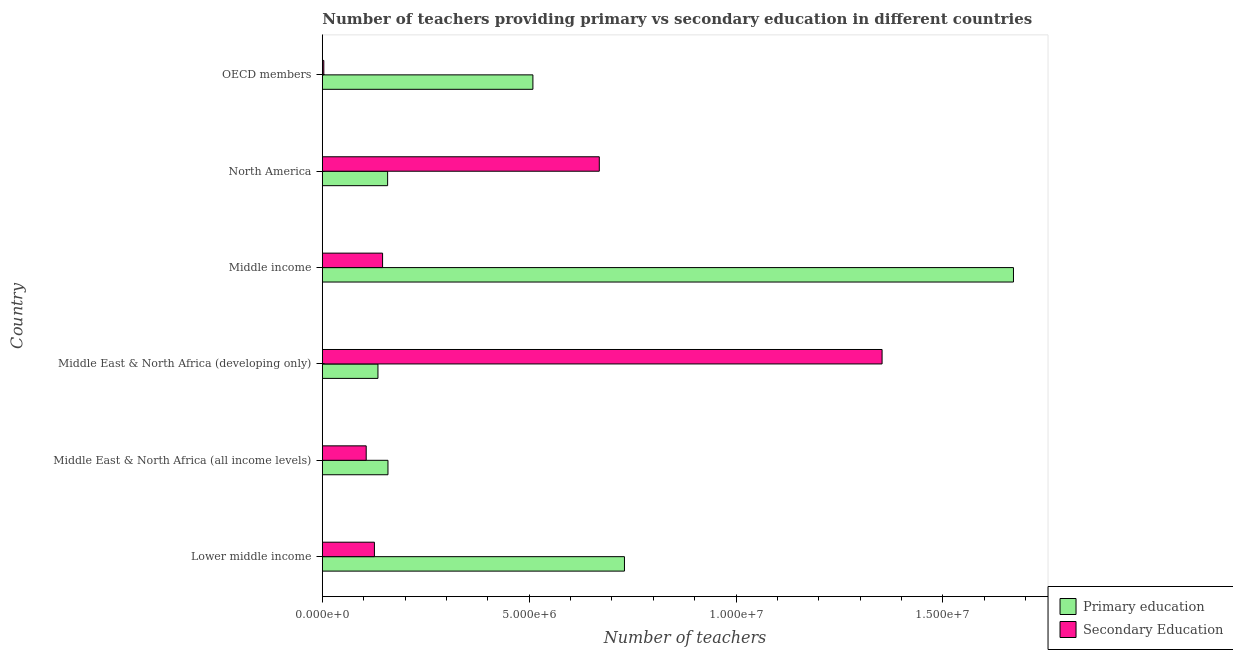How many groups of bars are there?
Keep it short and to the point. 6. How many bars are there on the 3rd tick from the bottom?
Provide a short and direct response. 2. What is the label of the 5th group of bars from the top?
Make the answer very short. Middle East & North Africa (all income levels). In how many cases, is the number of bars for a given country not equal to the number of legend labels?
Ensure brevity in your answer.  0. What is the number of secondary teachers in Middle income?
Provide a short and direct response. 1.46e+06. Across all countries, what is the maximum number of primary teachers?
Your answer should be compact. 1.67e+07. Across all countries, what is the minimum number of primary teachers?
Offer a very short reply. 1.34e+06. In which country was the number of secondary teachers maximum?
Give a very brief answer. Middle East & North Africa (developing only). In which country was the number of secondary teachers minimum?
Provide a succinct answer. OECD members. What is the total number of primary teachers in the graph?
Provide a succinct answer. 3.36e+07. What is the difference between the number of primary teachers in Middle East & North Africa (all income levels) and that in Middle income?
Your response must be concise. -1.51e+07. What is the difference between the number of secondary teachers in North America and the number of primary teachers in Middle East & North Africa (all income levels)?
Provide a short and direct response. 5.11e+06. What is the average number of primary teachers per country?
Keep it short and to the point. 5.60e+06. What is the difference between the number of primary teachers and number of secondary teachers in Middle income?
Your answer should be very brief. 1.52e+07. In how many countries, is the number of primary teachers greater than 10000000 ?
Ensure brevity in your answer.  1. What is the ratio of the number of primary teachers in Middle East & North Africa (developing only) to that in OECD members?
Keep it short and to the point. 0.26. Is the difference between the number of primary teachers in Lower middle income and Middle income greater than the difference between the number of secondary teachers in Lower middle income and Middle income?
Offer a very short reply. No. What is the difference between the highest and the second highest number of secondary teachers?
Make the answer very short. 6.83e+06. What is the difference between the highest and the lowest number of primary teachers?
Offer a very short reply. 1.54e+07. What does the 1st bar from the top in Middle East & North Africa (all income levels) represents?
Ensure brevity in your answer.  Secondary Education. What does the 2nd bar from the bottom in North America represents?
Provide a short and direct response. Secondary Education. How many bars are there?
Your answer should be very brief. 12. What is the difference between two consecutive major ticks on the X-axis?
Ensure brevity in your answer.  5.00e+06. Does the graph contain grids?
Your response must be concise. No. How are the legend labels stacked?
Offer a terse response. Vertical. What is the title of the graph?
Your answer should be very brief. Number of teachers providing primary vs secondary education in different countries. What is the label or title of the X-axis?
Provide a succinct answer. Number of teachers. What is the Number of teachers in Primary education in Lower middle income?
Your answer should be very brief. 7.30e+06. What is the Number of teachers of Secondary Education in Lower middle income?
Your answer should be compact. 1.26e+06. What is the Number of teachers of Primary education in Middle East & North Africa (all income levels)?
Provide a short and direct response. 1.59e+06. What is the Number of teachers in Secondary Education in Middle East & North Africa (all income levels)?
Ensure brevity in your answer.  1.06e+06. What is the Number of teachers in Primary education in Middle East & North Africa (developing only)?
Make the answer very short. 1.34e+06. What is the Number of teachers of Secondary Education in Middle East & North Africa (developing only)?
Keep it short and to the point. 1.35e+07. What is the Number of teachers of Primary education in Middle income?
Offer a terse response. 1.67e+07. What is the Number of teachers of Secondary Education in Middle income?
Ensure brevity in your answer.  1.46e+06. What is the Number of teachers in Primary education in North America?
Make the answer very short. 1.58e+06. What is the Number of teachers of Secondary Education in North America?
Give a very brief answer. 6.69e+06. What is the Number of teachers in Primary education in OECD members?
Offer a very short reply. 5.09e+06. What is the Number of teachers of Secondary Education in OECD members?
Your response must be concise. 3.58e+04. Across all countries, what is the maximum Number of teachers of Primary education?
Offer a terse response. 1.67e+07. Across all countries, what is the maximum Number of teachers in Secondary Education?
Ensure brevity in your answer.  1.35e+07. Across all countries, what is the minimum Number of teachers of Primary education?
Your answer should be very brief. 1.34e+06. Across all countries, what is the minimum Number of teachers of Secondary Education?
Make the answer very short. 3.58e+04. What is the total Number of teachers of Primary education in the graph?
Provide a short and direct response. 3.36e+07. What is the total Number of teachers in Secondary Education in the graph?
Keep it short and to the point. 2.40e+07. What is the difference between the Number of teachers of Primary education in Lower middle income and that in Middle East & North Africa (all income levels)?
Ensure brevity in your answer.  5.72e+06. What is the difference between the Number of teachers of Secondary Education in Lower middle income and that in Middle East & North Africa (all income levels)?
Your answer should be very brief. 1.99e+05. What is the difference between the Number of teachers of Primary education in Lower middle income and that in Middle East & North Africa (developing only)?
Ensure brevity in your answer.  5.96e+06. What is the difference between the Number of teachers of Secondary Education in Lower middle income and that in Middle East & North Africa (developing only)?
Your response must be concise. -1.23e+07. What is the difference between the Number of teachers of Primary education in Lower middle income and that in Middle income?
Ensure brevity in your answer.  -9.40e+06. What is the difference between the Number of teachers of Secondary Education in Lower middle income and that in Middle income?
Give a very brief answer. -1.97e+05. What is the difference between the Number of teachers of Primary education in Lower middle income and that in North America?
Your answer should be very brief. 5.72e+06. What is the difference between the Number of teachers in Secondary Education in Lower middle income and that in North America?
Give a very brief answer. -5.43e+06. What is the difference between the Number of teachers in Primary education in Lower middle income and that in OECD members?
Offer a terse response. 2.21e+06. What is the difference between the Number of teachers in Secondary Education in Lower middle income and that in OECD members?
Provide a succinct answer. 1.22e+06. What is the difference between the Number of teachers in Primary education in Middle East & North Africa (all income levels) and that in Middle East & North Africa (developing only)?
Provide a short and direct response. 2.42e+05. What is the difference between the Number of teachers of Secondary Education in Middle East & North Africa (all income levels) and that in Middle East & North Africa (developing only)?
Give a very brief answer. -1.25e+07. What is the difference between the Number of teachers in Primary education in Middle East & North Africa (all income levels) and that in Middle income?
Ensure brevity in your answer.  -1.51e+07. What is the difference between the Number of teachers of Secondary Education in Middle East & North Africa (all income levels) and that in Middle income?
Offer a terse response. -3.96e+05. What is the difference between the Number of teachers in Primary education in Middle East & North Africa (all income levels) and that in North America?
Provide a short and direct response. 8263.25. What is the difference between the Number of teachers of Secondary Education in Middle East & North Africa (all income levels) and that in North America?
Make the answer very short. -5.63e+06. What is the difference between the Number of teachers of Primary education in Middle East & North Africa (all income levels) and that in OECD members?
Keep it short and to the point. -3.50e+06. What is the difference between the Number of teachers in Secondary Education in Middle East & North Africa (all income levels) and that in OECD members?
Ensure brevity in your answer.  1.02e+06. What is the difference between the Number of teachers of Primary education in Middle East & North Africa (developing only) and that in Middle income?
Provide a succinct answer. -1.54e+07. What is the difference between the Number of teachers of Secondary Education in Middle East & North Africa (developing only) and that in Middle income?
Give a very brief answer. 1.21e+07. What is the difference between the Number of teachers in Primary education in Middle East & North Africa (developing only) and that in North America?
Offer a terse response. -2.34e+05. What is the difference between the Number of teachers of Secondary Education in Middle East & North Africa (developing only) and that in North America?
Make the answer very short. 6.83e+06. What is the difference between the Number of teachers of Primary education in Middle East & North Africa (developing only) and that in OECD members?
Provide a short and direct response. -3.74e+06. What is the difference between the Number of teachers of Secondary Education in Middle East & North Africa (developing only) and that in OECD members?
Offer a very short reply. 1.35e+07. What is the difference between the Number of teachers in Primary education in Middle income and that in North America?
Offer a very short reply. 1.51e+07. What is the difference between the Number of teachers in Secondary Education in Middle income and that in North America?
Your answer should be very brief. -5.24e+06. What is the difference between the Number of teachers in Primary education in Middle income and that in OECD members?
Your answer should be very brief. 1.16e+07. What is the difference between the Number of teachers of Secondary Education in Middle income and that in OECD members?
Keep it short and to the point. 1.42e+06. What is the difference between the Number of teachers in Primary education in North America and that in OECD members?
Your answer should be very brief. -3.51e+06. What is the difference between the Number of teachers of Secondary Education in North America and that in OECD members?
Offer a terse response. 6.66e+06. What is the difference between the Number of teachers in Primary education in Lower middle income and the Number of teachers in Secondary Education in Middle East & North Africa (all income levels)?
Keep it short and to the point. 6.24e+06. What is the difference between the Number of teachers in Primary education in Lower middle income and the Number of teachers in Secondary Education in Middle East & North Africa (developing only)?
Your response must be concise. -6.23e+06. What is the difference between the Number of teachers in Primary education in Lower middle income and the Number of teachers in Secondary Education in Middle income?
Ensure brevity in your answer.  5.85e+06. What is the difference between the Number of teachers in Primary education in Lower middle income and the Number of teachers in Secondary Education in North America?
Your answer should be compact. 6.08e+05. What is the difference between the Number of teachers in Primary education in Lower middle income and the Number of teachers in Secondary Education in OECD members?
Provide a short and direct response. 7.27e+06. What is the difference between the Number of teachers of Primary education in Middle East & North Africa (all income levels) and the Number of teachers of Secondary Education in Middle East & North Africa (developing only)?
Offer a very short reply. -1.19e+07. What is the difference between the Number of teachers in Primary education in Middle East & North Africa (all income levels) and the Number of teachers in Secondary Education in Middle income?
Keep it short and to the point. 1.30e+05. What is the difference between the Number of teachers in Primary education in Middle East & North Africa (all income levels) and the Number of teachers in Secondary Education in North America?
Make the answer very short. -5.11e+06. What is the difference between the Number of teachers of Primary education in Middle East & North Africa (all income levels) and the Number of teachers of Secondary Education in OECD members?
Your response must be concise. 1.55e+06. What is the difference between the Number of teachers of Primary education in Middle East & North Africa (developing only) and the Number of teachers of Secondary Education in Middle income?
Your answer should be very brief. -1.11e+05. What is the difference between the Number of teachers in Primary education in Middle East & North Africa (developing only) and the Number of teachers in Secondary Education in North America?
Provide a short and direct response. -5.35e+06. What is the difference between the Number of teachers in Primary education in Middle East & North Africa (developing only) and the Number of teachers in Secondary Education in OECD members?
Provide a short and direct response. 1.31e+06. What is the difference between the Number of teachers in Primary education in Middle income and the Number of teachers in Secondary Education in North America?
Your answer should be compact. 1.00e+07. What is the difference between the Number of teachers of Primary education in Middle income and the Number of teachers of Secondary Education in OECD members?
Ensure brevity in your answer.  1.67e+07. What is the difference between the Number of teachers in Primary education in North America and the Number of teachers in Secondary Education in OECD members?
Provide a short and direct response. 1.54e+06. What is the average Number of teachers of Primary education per country?
Your answer should be compact. 5.60e+06. What is the average Number of teachers in Secondary Education per country?
Your answer should be compact. 4.01e+06. What is the difference between the Number of teachers of Primary education and Number of teachers of Secondary Education in Lower middle income?
Provide a short and direct response. 6.04e+06. What is the difference between the Number of teachers of Primary education and Number of teachers of Secondary Education in Middle East & North Africa (all income levels)?
Your answer should be very brief. 5.26e+05. What is the difference between the Number of teachers of Primary education and Number of teachers of Secondary Education in Middle East & North Africa (developing only)?
Offer a very short reply. -1.22e+07. What is the difference between the Number of teachers in Primary education and Number of teachers in Secondary Education in Middle income?
Provide a succinct answer. 1.52e+07. What is the difference between the Number of teachers in Primary education and Number of teachers in Secondary Education in North America?
Provide a succinct answer. -5.12e+06. What is the difference between the Number of teachers in Primary education and Number of teachers in Secondary Education in OECD members?
Offer a very short reply. 5.05e+06. What is the ratio of the Number of teachers in Primary education in Lower middle income to that in Middle East & North Africa (all income levels)?
Your response must be concise. 4.6. What is the ratio of the Number of teachers of Secondary Education in Lower middle income to that in Middle East & North Africa (all income levels)?
Offer a terse response. 1.19. What is the ratio of the Number of teachers in Primary education in Lower middle income to that in Middle East & North Africa (developing only)?
Give a very brief answer. 5.43. What is the ratio of the Number of teachers in Secondary Education in Lower middle income to that in Middle East & North Africa (developing only)?
Your answer should be compact. 0.09. What is the ratio of the Number of teachers of Primary education in Lower middle income to that in Middle income?
Ensure brevity in your answer.  0.44. What is the ratio of the Number of teachers of Secondary Education in Lower middle income to that in Middle income?
Give a very brief answer. 0.86. What is the ratio of the Number of teachers in Primary education in Lower middle income to that in North America?
Provide a short and direct response. 4.63. What is the ratio of the Number of teachers of Secondary Education in Lower middle income to that in North America?
Your response must be concise. 0.19. What is the ratio of the Number of teachers in Primary education in Lower middle income to that in OECD members?
Your response must be concise. 1.43. What is the ratio of the Number of teachers in Secondary Education in Lower middle income to that in OECD members?
Your response must be concise. 35.21. What is the ratio of the Number of teachers in Primary education in Middle East & North Africa (all income levels) to that in Middle East & North Africa (developing only)?
Offer a very short reply. 1.18. What is the ratio of the Number of teachers in Secondary Education in Middle East & North Africa (all income levels) to that in Middle East & North Africa (developing only)?
Your answer should be compact. 0.08. What is the ratio of the Number of teachers in Primary education in Middle East & North Africa (all income levels) to that in Middle income?
Offer a very short reply. 0.1. What is the ratio of the Number of teachers in Secondary Education in Middle East & North Africa (all income levels) to that in Middle income?
Provide a short and direct response. 0.73. What is the ratio of the Number of teachers of Secondary Education in Middle East & North Africa (all income levels) to that in North America?
Offer a terse response. 0.16. What is the ratio of the Number of teachers of Primary education in Middle East & North Africa (all income levels) to that in OECD members?
Give a very brief answer. 0.31. What is the ratio of the Number of teachers of Secondary Education in Middle East & North Africa (all income levels) to that in OECD members?
Your answer should be compact. 29.65. What is the ratio of the Number of teachers in Primary education in Middle East & North Africa (developing only) to that in Middle income?
Provide a short and direct response. 0.08. What is the ratio of the Number of teachers in Secondary Education in Middle East & North Africa (developing only) to that in Middle income?
Provide a short and direct response. 9.29. What is the ratio of the Number of teachers in Primary education in Middle East & North Africa (developing only) to that in North America?
Your response must be concise. 0.85. What is the ratio of the Number of teachers of Secondary Education in Middle East & North Africa (developing only) to that in North America?
Give a very brief answer. 2.02. What is the ratio of the Number of teachers of Primary education in Middle East & North Africa (developing only) to that in OECD members?
Your response must be concise. 0.26. What is the ratio of the Number of teachers of Secondary Education in Middle East & North Africa (developing only) to that in OECD members?
Your answer should be very brief. 378.38. What is the ratio of the Number of teachers in Primary education in Middle income to that in North America?
Give a very brief answer. 10.58. What is the ratio of the Number of teachers of Secondary Education in Middle income to that in North America?
Your response must be concise. 0.22. What is the ratio of the Number of teachers in Primary education in Middle income to that in OECD members?
Ensure brevity in your answer.  3.28. What is the ratio of the Number of teachers in Secondary Education in Middle income to that in OECD members?
Your answer should be very brief. 40.72. What is the ratio of the Number of teachers in Primary education in North America to that in OECD members?
Offer a terse response. 0.31. What is the ratio of the Number of teachers of Secondary Education in North America to that in OECD members?
Your answer should be compact. 187.22. What is the difference between the highest and the second highest Number of teachers of Primary education?
Provide a succinct answer. 9.40e+06. What is the difference between the highest and the second highest Number of teachers of Secondary Education?
Ensure brevity in your answer.  6.83e+06. What is the difference between the highest and the lowest Number of teachers in Primary education?
Your response must be concise. 1.54e+07. What is the difference between the highest and the lowest Number of teachers in Secondary Education?
Give a very brief answer. 1.35e+07. 